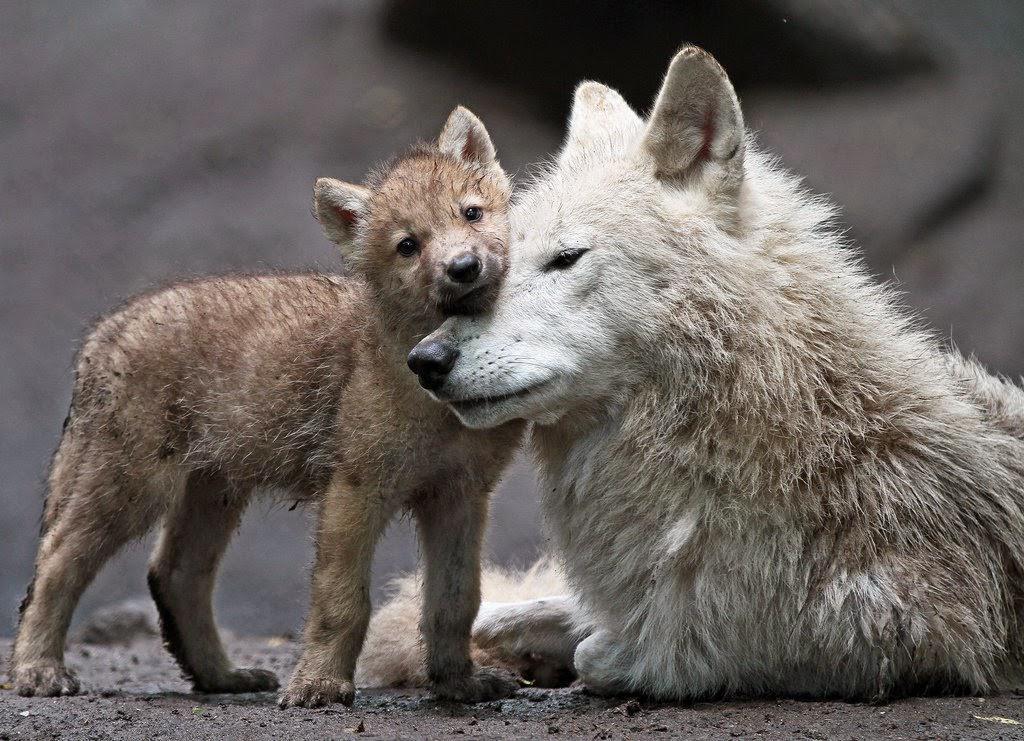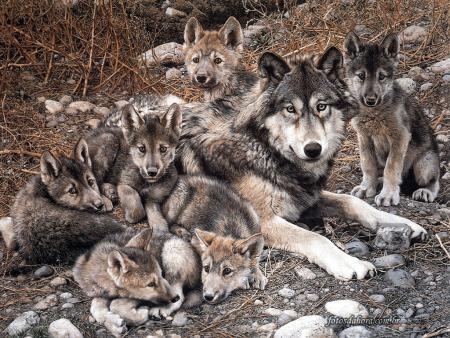The first image is the image on the left, the second image is the image on the right. Considering the images on both sides, is "There is no more than three wolves in the right image." valid? Answer yes or no. No. 